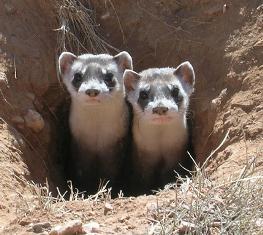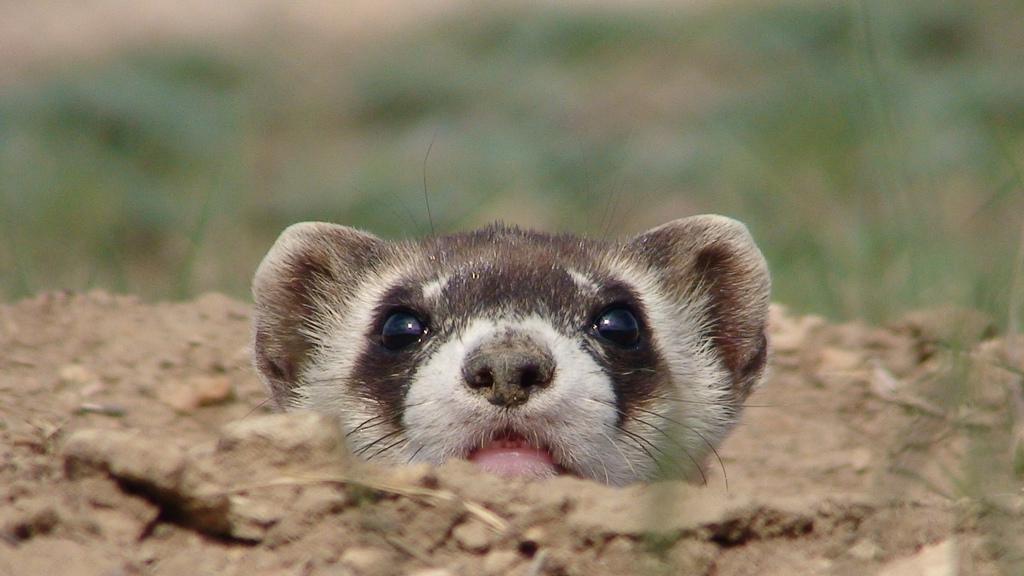The first image is the image on the left, the second image is the image on the right. Assess this claim about the two images: "There are exactly 4 animals.". Correct or not? Answer yes or no. No. The first image is the image on the left, the second image is the image on the right. Considering the images on both sides, is "A total of four ferrets are shown, all sticking their heads up above the surface of the ground." valid? Answer yes or no. No. 